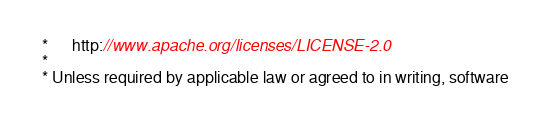Convert code to text. <code><loc_0><loc_0><loc_500><loc_500><_Java_> *      http://www.apache.org/licenses/LICENSE-2.0
 *
 * Unless required by applicable law or agreed to in writing, software</code> 